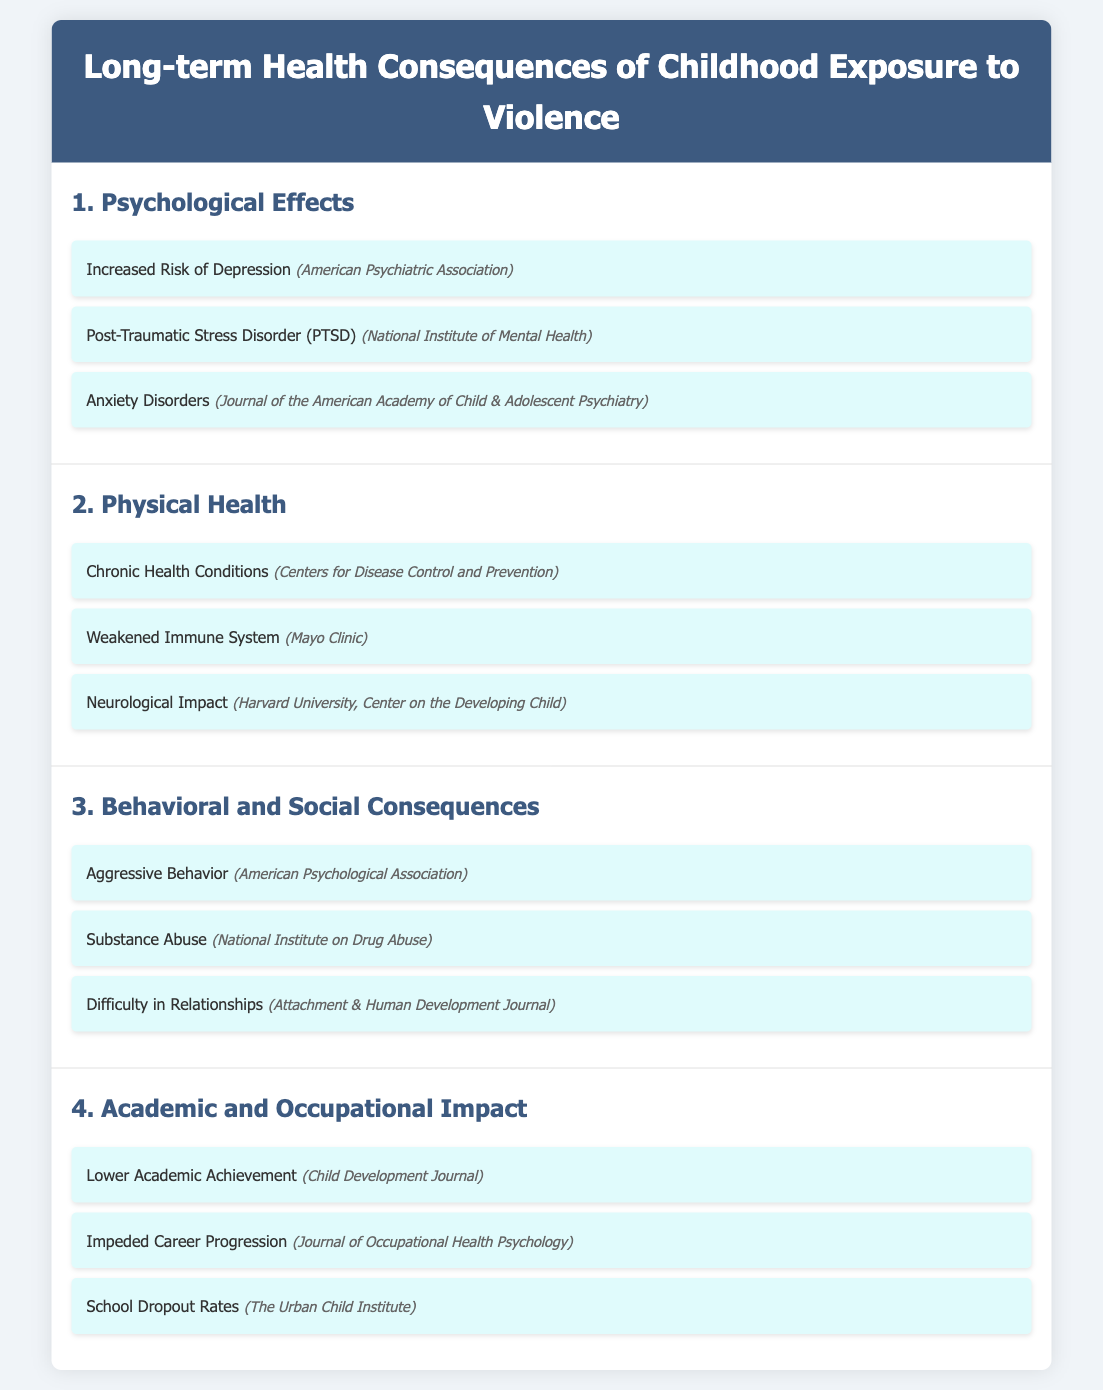What is one psychological effect of childhood exposure to violence? The document lists increased risk of depression as one of the psychological effects.
Answer: Increased Risk of Depression What chronic condition is mentioned as a physical health consequence? The document states chronic health conditions as a physical health consequence of violence exposure.
Answer: Chronic Health Conditions Which organization reports on the risk of PTSD? The National Institute of Mental Health is cited in the document as the organization reporting on PTSD.
Answer: National Institute of Mental Health What is one behavioral consequence associated with childhood exposure to violence? The document lists aggressive behavior as a behavioral consequence of exposure to violence.
Answer: Aggressive Behavior Which publication discusses the impact on academic achievement? The Child Development Journal is referenced in the document concerning academic impact.
Answer: Child Development Journal How many sections are included in the infographic? The document contains four distinct sections covering various consequences.
Answer: Four What type of health consequence relates to a weakened immune system? The document indicates that a weakened immune system is a physical health consequence.
Answer: Physical Health What is mentioned as a social consequence of violence exposure? Difficulty in relationships is highlighted in the document as a social consequence.
Answer: Difficulty in Relationships Which source is mentioned for the neurological impact? The document cites Harvard University, Center on the Developing Child as the source for neurological impact.
Answer: Harvard University, Center on the Developing Child 